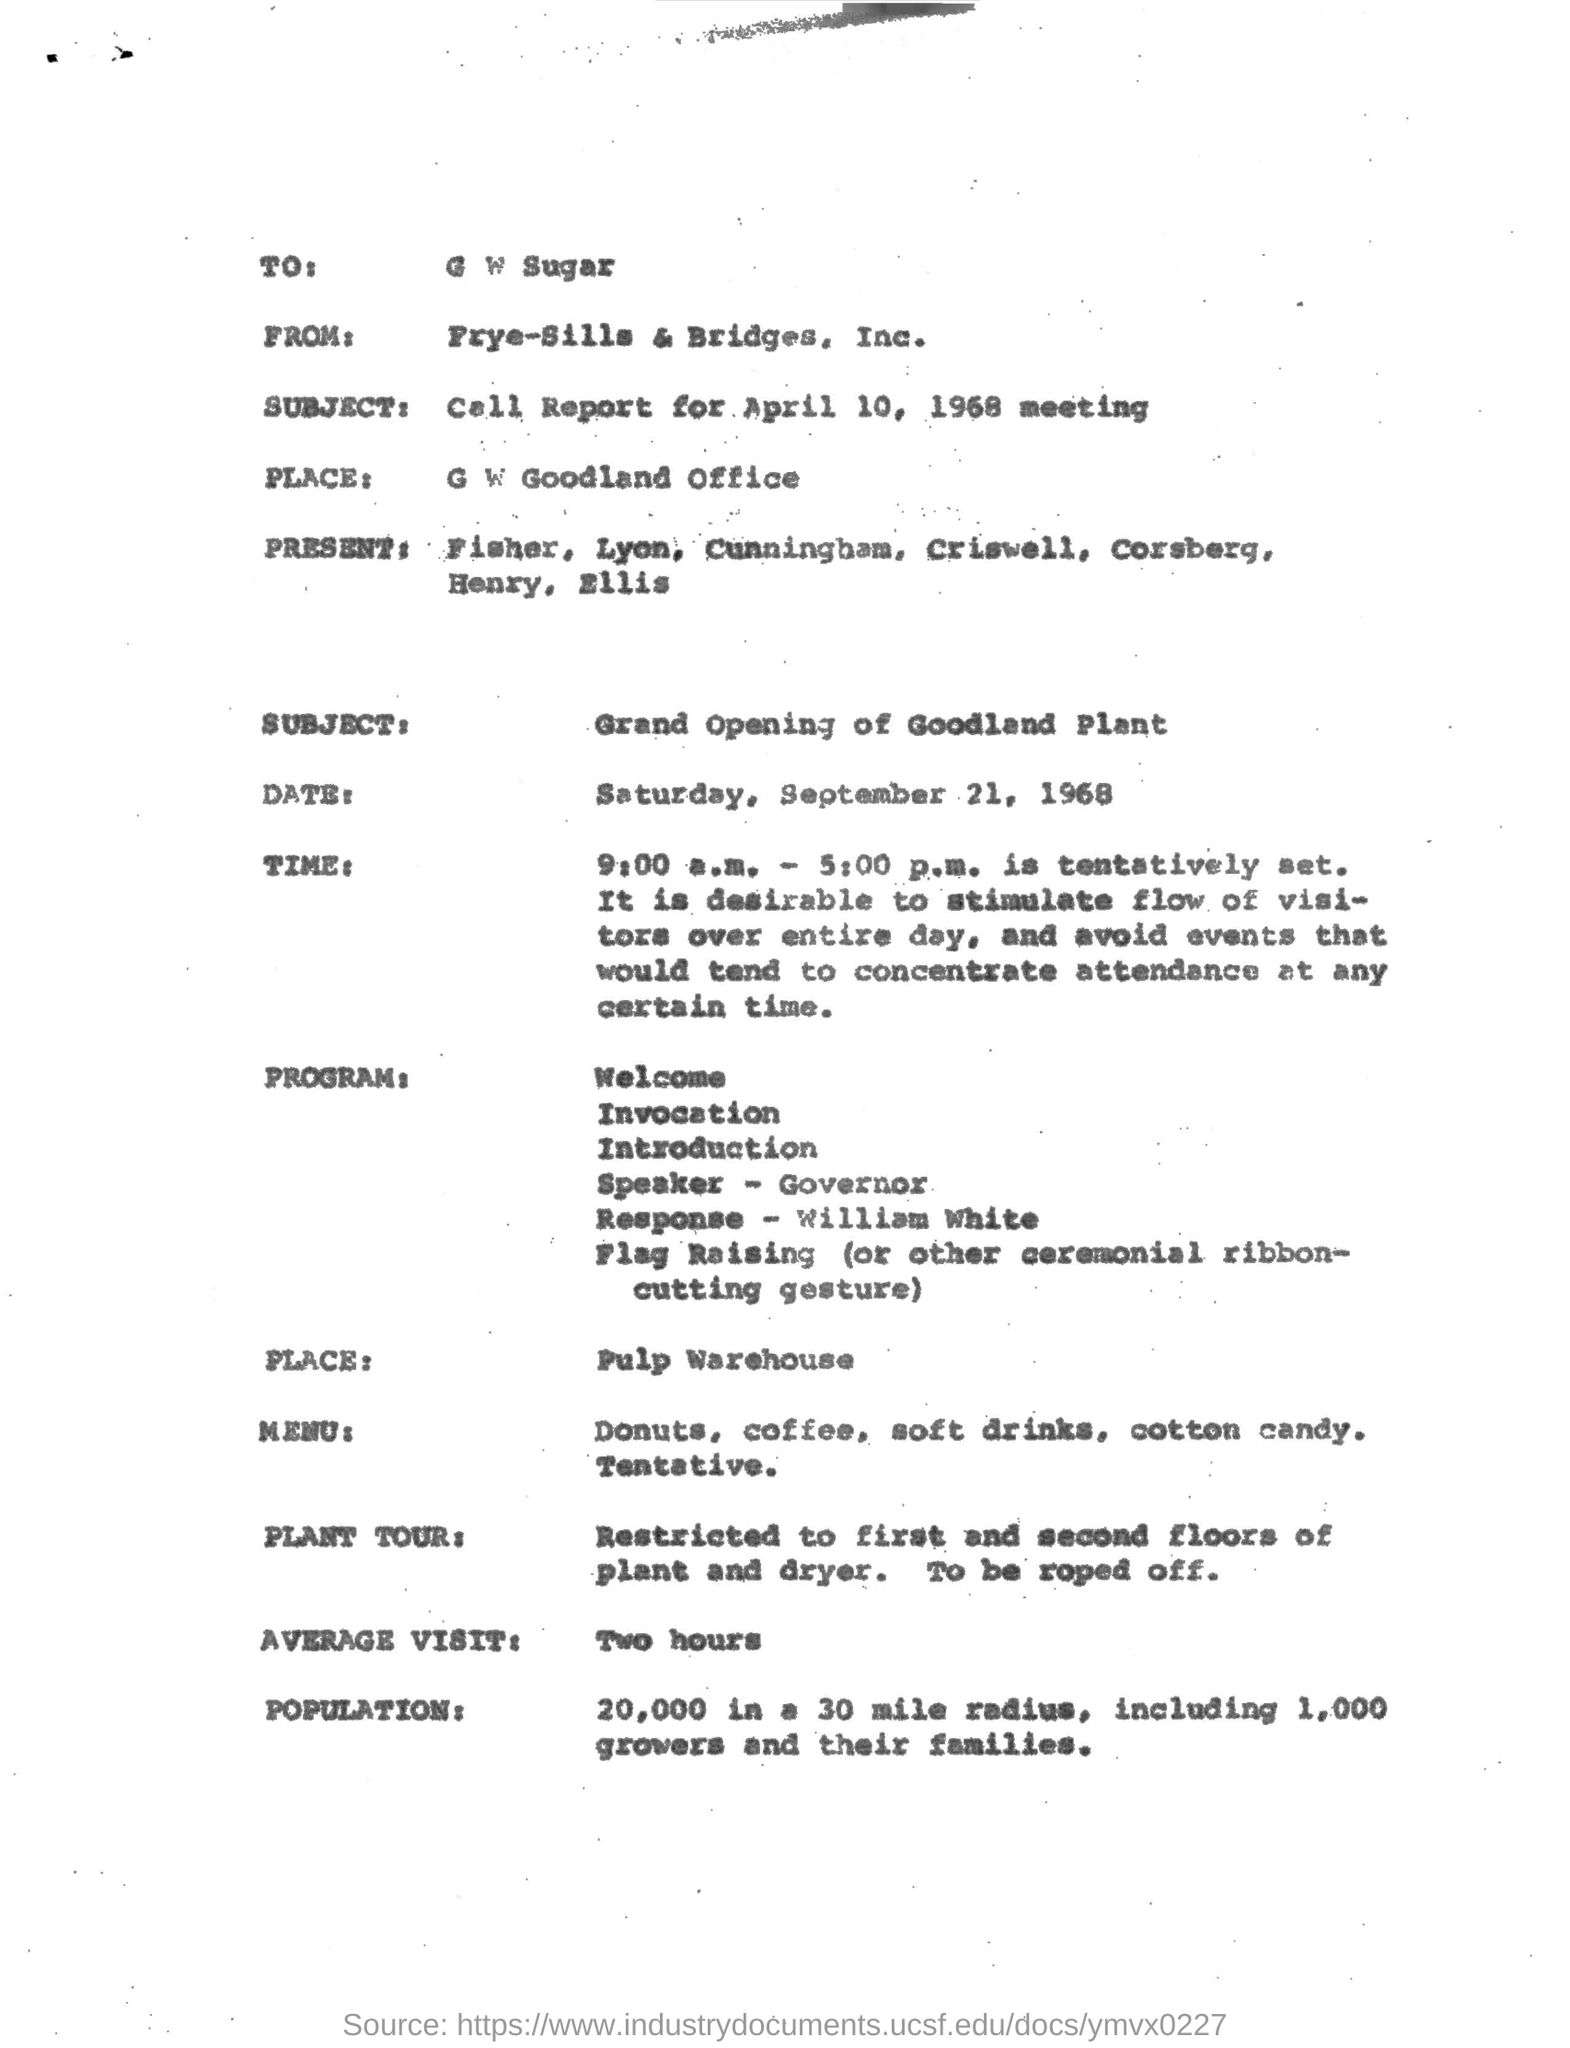How much is the "Average visit"?
Offer a very short reply. Two hours. To Whom is this letter addressed to?
Offer a very short reply. G W SUGAR. 